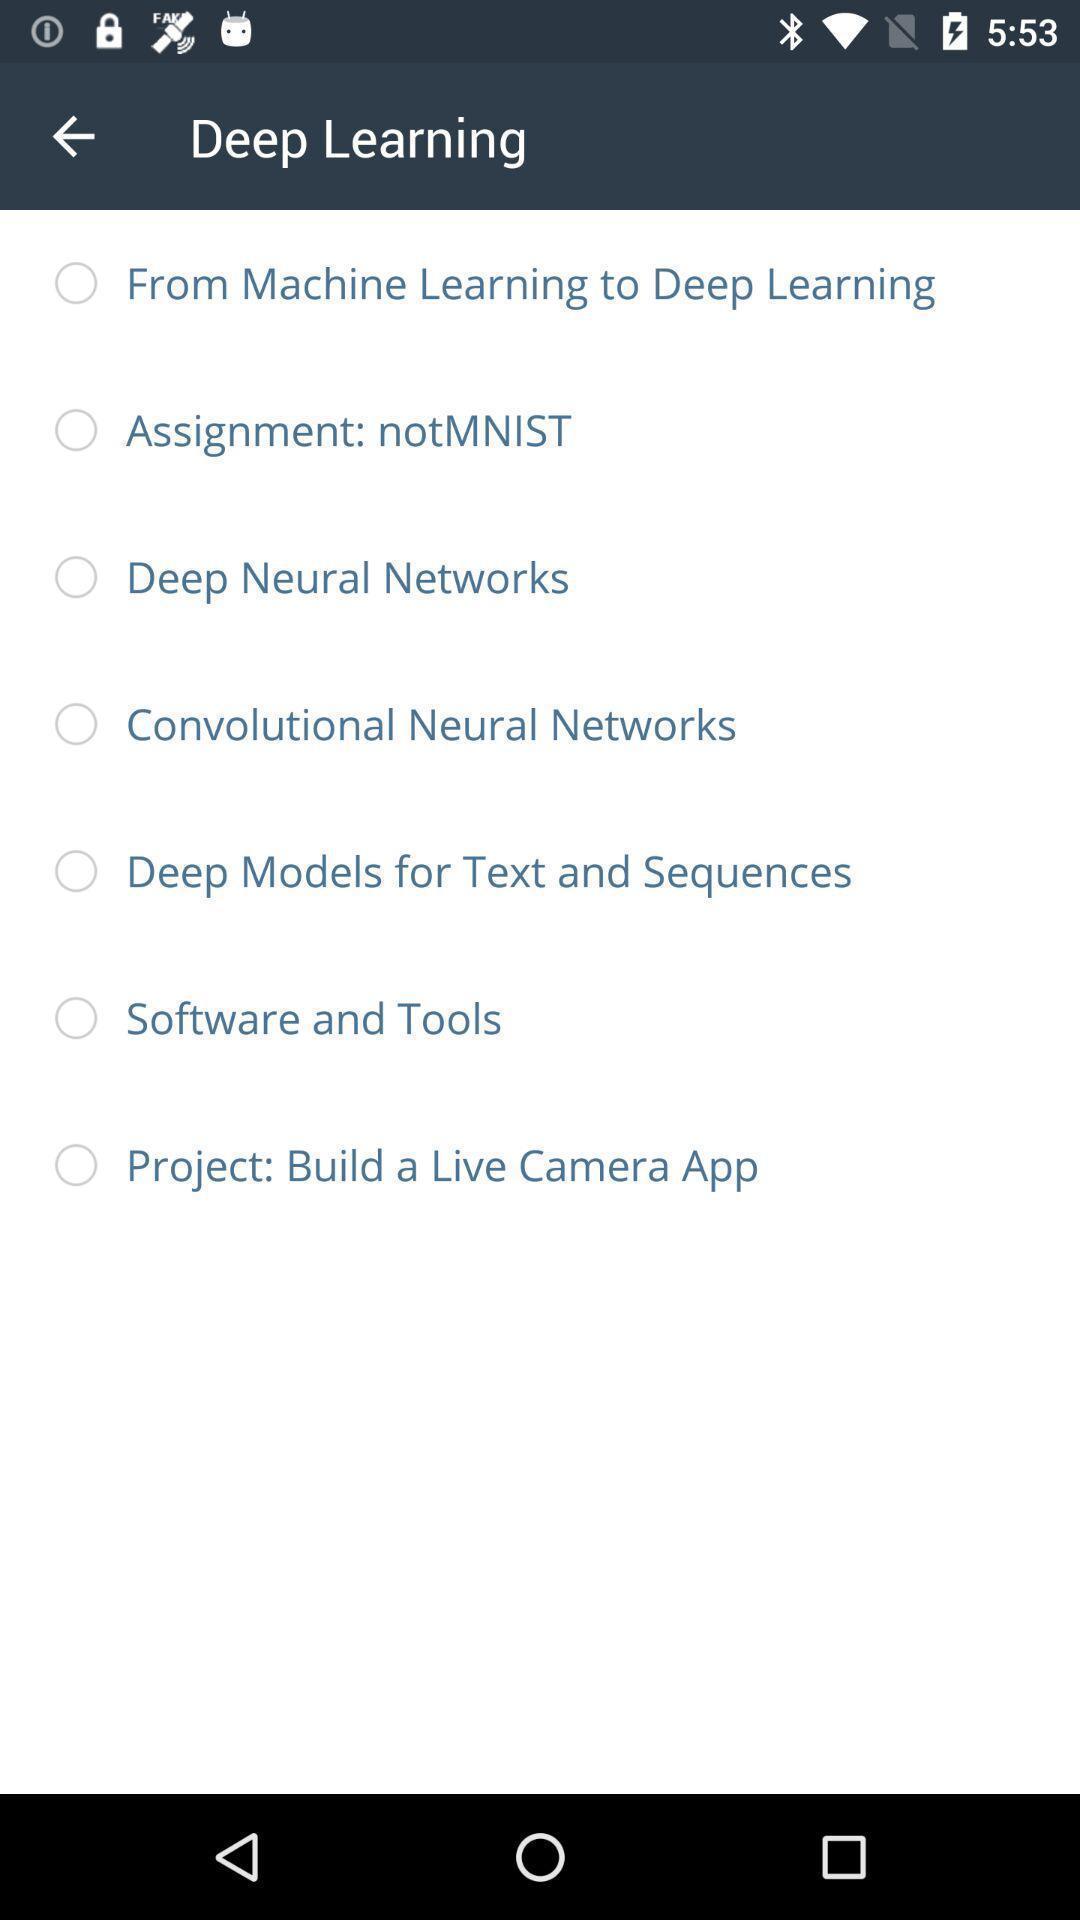Explain the elements present in this screenshot. Page showing multiple options with radio buttons. 